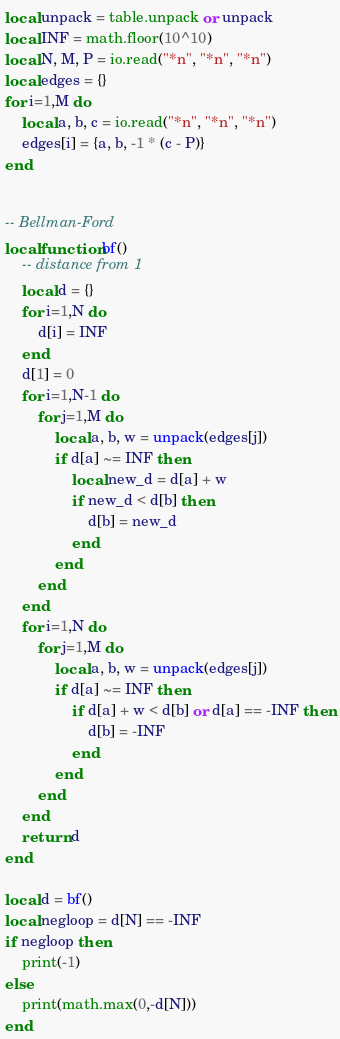<code> <loc_0><loc_0><loc_500><loc_500><_Lua_>local unpack = table.unpack or unpack
local INF = math.floor(10^10)
local N, M, P = io.read("*n", "*n", "*n")
local edges = {}
for i=1,M do
    local a, b, c = io.read("*n", "*n", "*n")
    edges[i] = {a, b, -1 * (c - P)}
end


-- Bellman-Ford
local function bf()
    -- distance from 1
    local d = {}
    for i=1,N do
        d[i] = INF
    end
    d[1] = 0
    for i=1,N-1 do
        for j=1,M do
            local a, b, w = unpack(edges[j])
            if d[a] ~= INF then
                local new_d = d[a] + w
                if new_d < d[b] then
                    d[b] = new_d
                end
            end
        end
    end
    for i=1,N do
        for j=1,M do
            local a, b, w = unpack(edges[j])
            if d[a] ~= INF then
                if d[a] + w < d[b] or d[a] == -INF then
                    d[b] = -INF
                end
            end
        end
    end
    return d
end

local d = bf()
local negloop = d[N] == -INF
if negloop then
    print(-1)
else
    print(math.max(0,-d[N]))
end</code> 